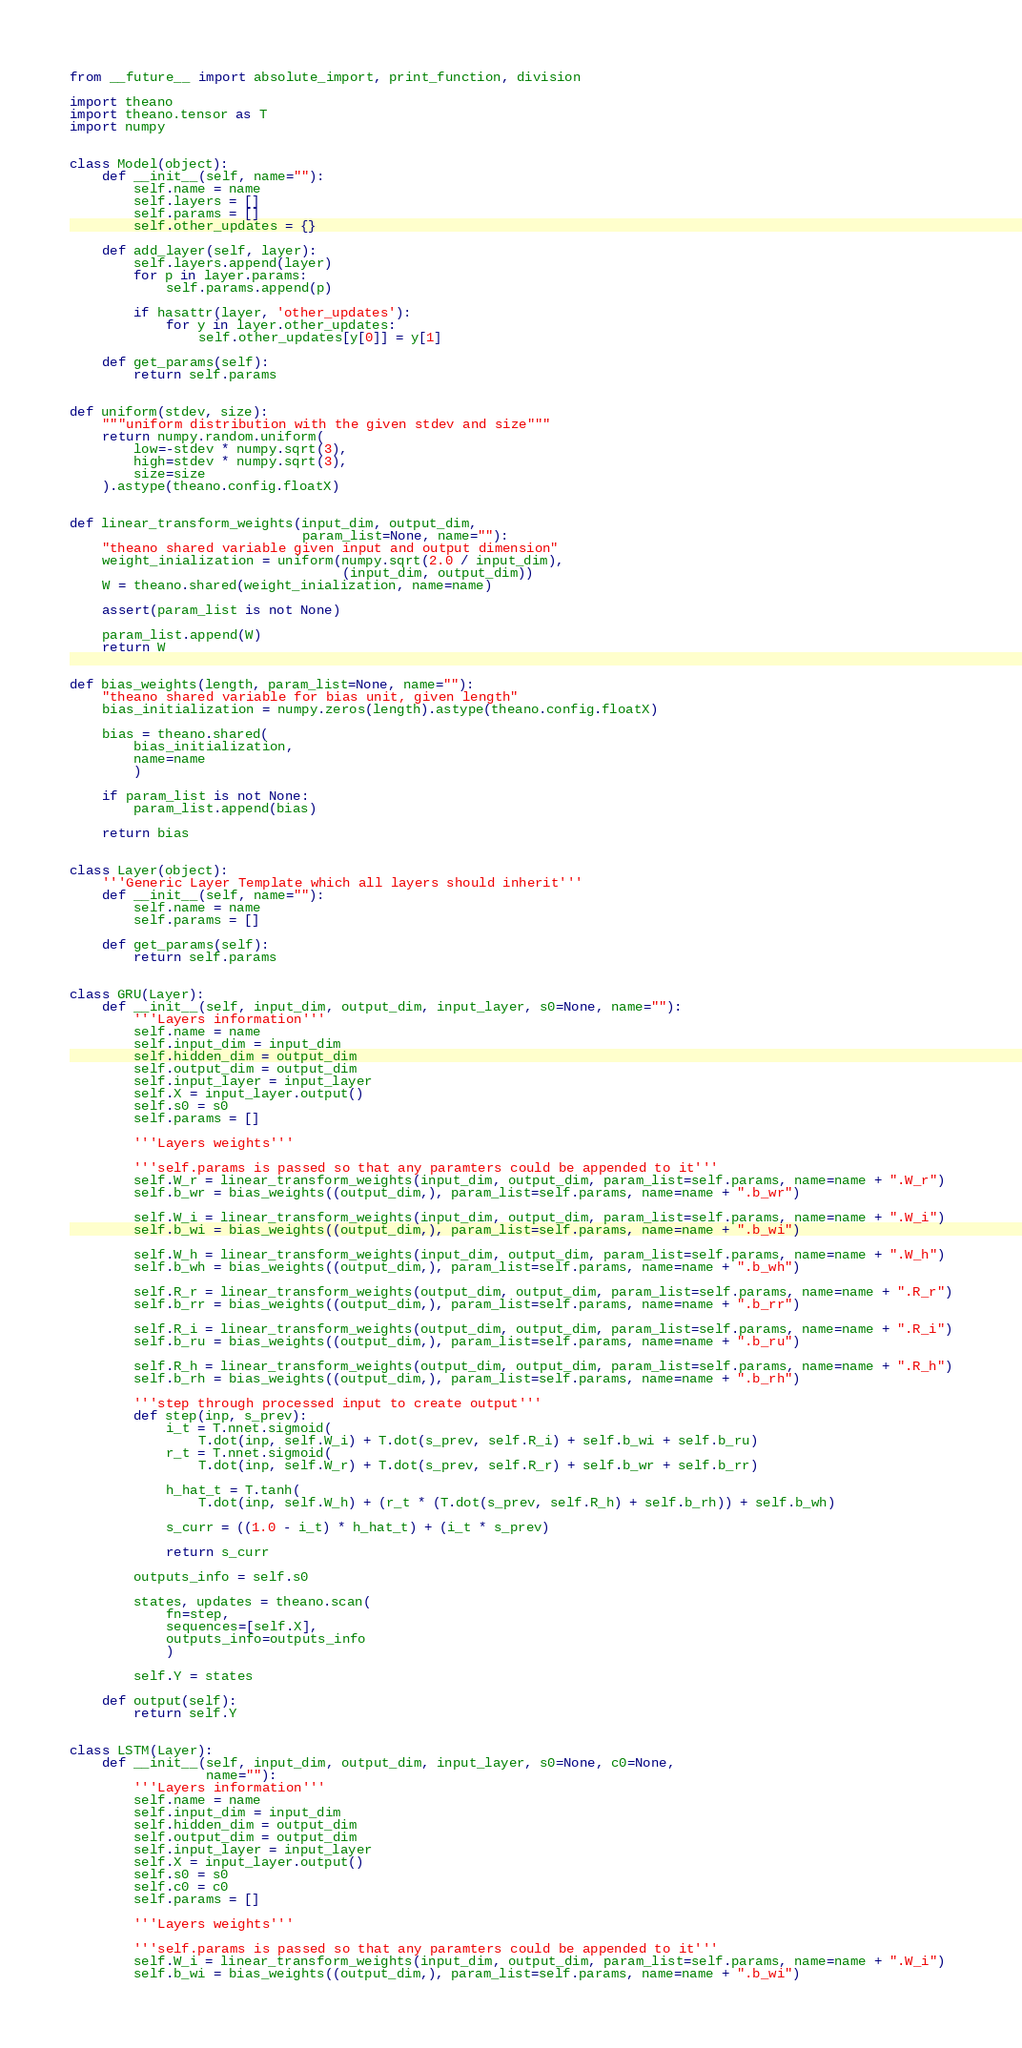Convert code to text. <code><loc_0><loc_0><loc_500><loc_500><_Python_>from __future__ import absolute_import, print_function, division

import theano
import theano.tensor as T
import numpy


class Model(object):
    def __init__(self, name=""):
        self.name = name
        self.layers = []
        self.params = []
        self.other_updates = {}

    def add_layer(self, layer):
        self.layers.append(layer)
        for p in layer.params:
            self.params.append(p)

        if hasattr(layer, 'other_updates'):
            for y in layer.other_updates:
                self.other_updates[y[0]] = y[1]

    def get_params(self):
        return self.params


def uniform(stdev, size):
    """uniform distribution with the given stdev and size"""
    return numpy.random.uniform(
        low=-stdev * numpy.sqrt(3),
        high=stdev * numpy.sqrt(3),
        size=size
    ).astype(theano.config.floatX)


def linear_transform_weights(input_dim, output_dim,
                             param_list=None, name=""):
    "theano shared variable given input and output dimension"
    weight_inialization = uniform(numpy.sqrt(2.0 / input_dim),
                                  (input_dim, output_dim))
    W = theano.shared(weight_inialization, name=name)

    assert(param_list is not None)

    param_list.append(W)
    return W


def bias_weights(length, param_list=None, name=""):
    "theano shared variable for bias unit, given length"
    bias_initialization = numpy.zeros(length).astype(theano.config.floatX)

    bias = theano.shared(
        bias_initialization,
        name=name
        )

    if param_list is not None:
        param_list.append(bias)

    return bias


class Layer(object):
    '''Generic Layer Template which all layers should inherit'''
    def __init__(self, name=""):
        self.name = name
        self.params = []

    def get_params(self):
        return self.params


class GRU(Layer):
    def __init__(self, input_dim, output_dim, input_layer, s0=None, name=""):
        '''Layers information'''
        self.name = name
        self.input_dim = input_dim
        self.hidden_dim = output_dim
        self.output_dim = output_dim
        self.input_layer = input_layer
        self.X = input_layer.output()
        self.s0 = s0
        self.params = []

        '''Layers weights'''

        '''self.params is passed so that any paramters could be appended to it'''
        self.W_r = linear_transform_weights(input_dim, output_dim, param_list=self.params, name=name + ".W_r")
        self.b_wr = bias_weights((output_dim,), param_list=self.params, name=name + ".b_wr")

        self.W_i = linear_transform_weights(input_dim, output_dim, param_list=self.params, name=name + ".W_i")
        self.b_wi = bias_weights((output_dim,), param_list=self.params, name=name + ".b_wi")

        self.W_h = linear_transform_weights(input_dim, output_dim, param_list=self.params, name=name + ".W_h")
        self.b_wh = bias_weights((output_dim,), param_list=self.params, name=name + ".b_wh")

        self.R_r = linear_transform_weights(output_dim, output_dim, param_list=self.params, name=name + ".R_r")
        self.b_rr = bias_weights((output_dim,), param_list=self.params, name=name + ".b_rr")

        self.R_i = linear_transform_weights(output_dim, output_dim, param_list=self.params, name=name + ".R_i")
        self.b_ru = bias_weights((output_dim,), param_list=self.params, name=name + ".b_ru")

        self.R_h = linear_transform_weights(output_dim, output_dim, param_list=self.params, name=name + ".R_h")
        self.b_rh = bias_weights((output_dim,), param_list=self.params, name=name + ".b_rh")

        '''step through processed input to create output'''
        def step(inp, s_prev):
            i_t = T.nnet.sigmoid(
                T.dot(inp, self.W_i) + T.dot(s_prev, self.R_i) + self.b_wi + self.b_ru)
            r_t = T.nnet.sigmoid(
                T.dot(inp, self.W_r) + T.dot(s_prev, self.R_r) + self.b_wr + self.b_rr)

            h_hat_t = T.tanh(
                T.dot(inp, self.W_h) + (r_t * (T.dot(s_prev, self.R_h) + self.b_rh)) + self.b_wh)

            s_curr = ((1.0 - i_t) * h_hat_t) + (i_t * s_prev)

            return s_curr

        outputs_info = self.s0

        states, updates = theano.scan(
            fn=step,
            sequences=[self.X],
            outputs_info=outputs_info
            )

        self.Y = states

    def output(self):
        return self.Y


class LSTM(Layer):
    def __init__(self, input_dim, output_dim, input_layer, s0=None, c0=None,
                 name=""):
        '''Layers information'''
        self.name = name
        self.input_dim = input_dim
        self.hidden_dim = output_dim
        self.output_dim = output_dim
        self.input_layer = input_layer
        self.X = input_layer.output()
        self.s0 = s0
        self.c0 = c0
        self.params = []

        '''Layers weights'''

        '''self.params is passed so that any paramters could be appended to it'''
        self.W_i = linear_transform_weights(input_dim, output_dim, param_list=self.params, name=name + ".W_i")
        self.b_wi = bias_weights((output_dim,), param_list=self.params, name=name + ".b_wi")
</code> 